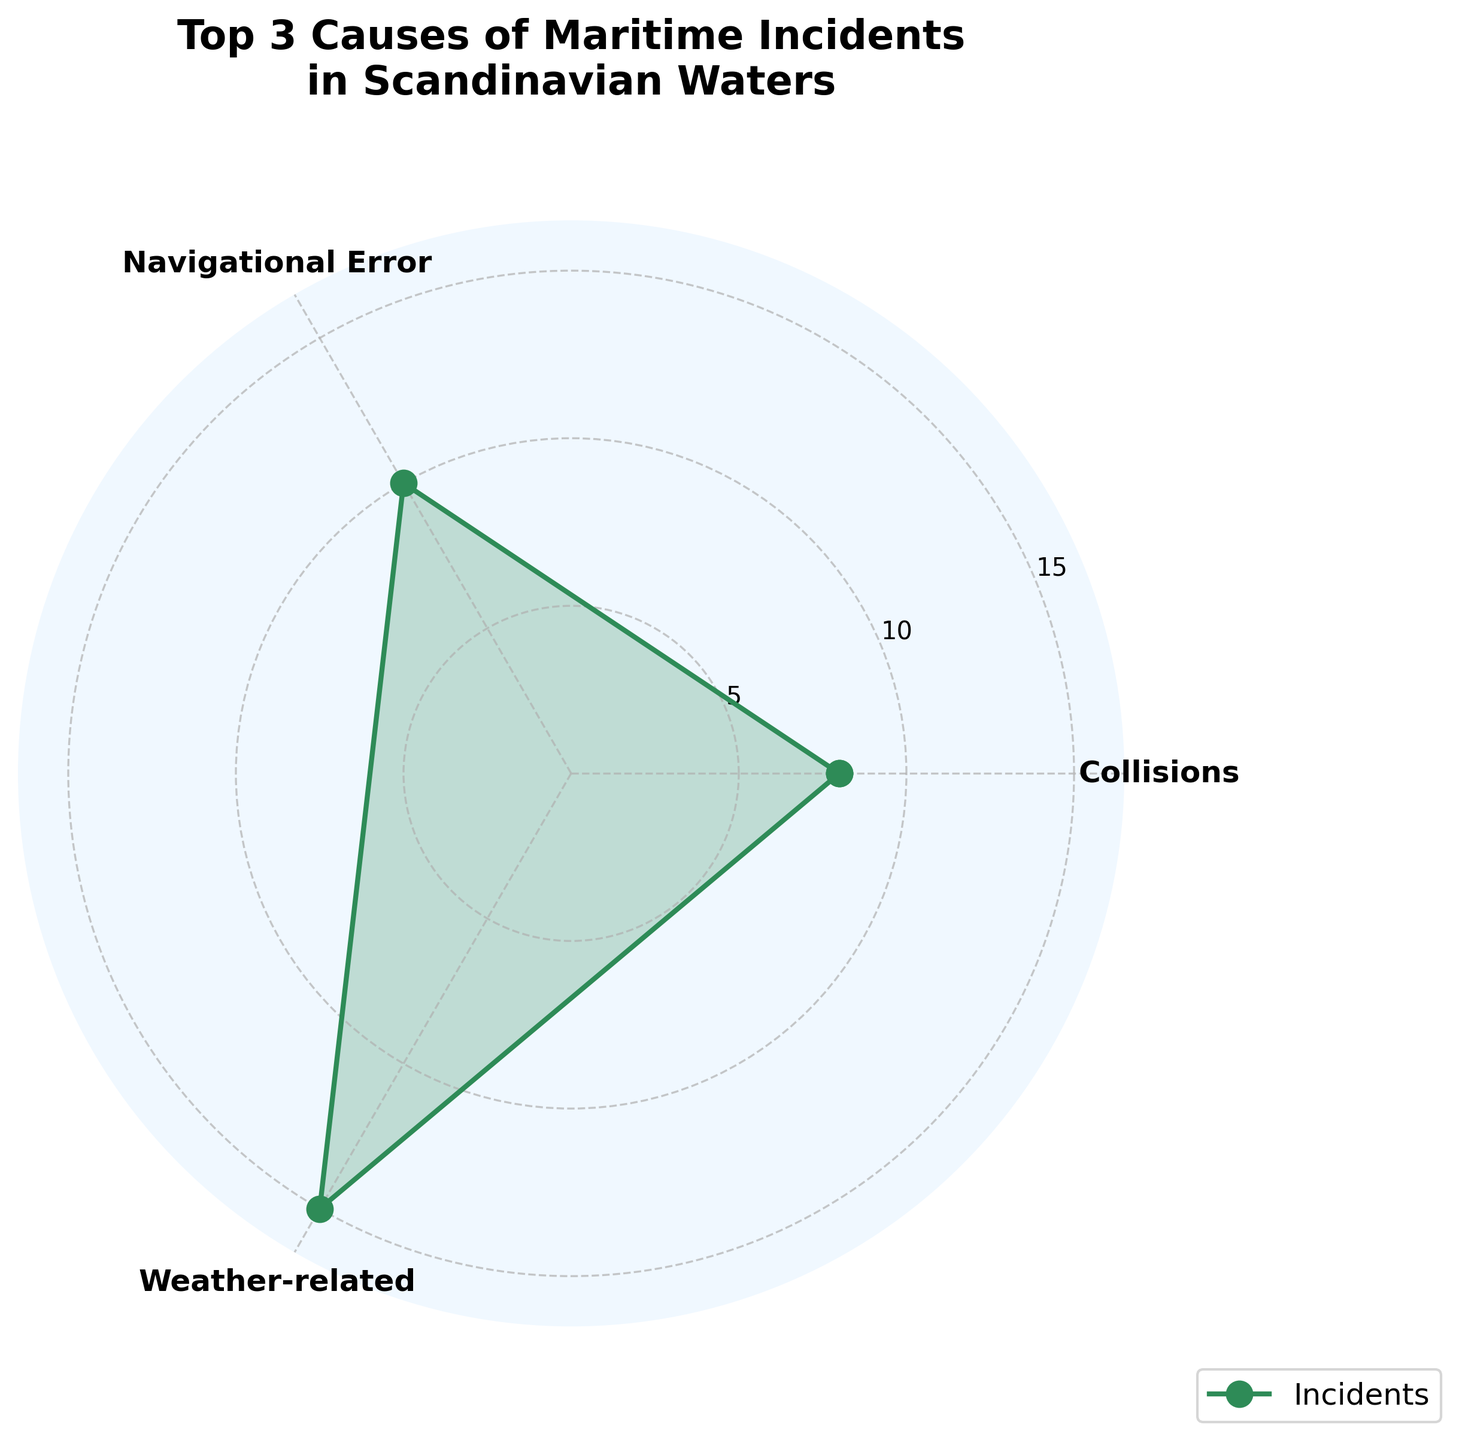What is the title of the figure? The title of the figure is displayed at the top in a large and bold font.
Answer: Top 3 Causes of Maritime Incidents in Scandinavian Waters How many causes are depicted in the rose chart? Count the number of unique labels on the angular axis of the rose chart.
Answer: 3 Which cause has the most incidents? Observe the length of the plots on the radial axis and identify which is the longest.
Answer: Weather-related How many incidents are related to navigational errors? Observe the label "Navigational Error" and note the value at that angular point.
Answer: 10 Which cause has the least number of incidents among the top 3? Compare the lengths of the plots and determine which is the shortest.
Answer: Mechanical Failure What is the total number of incidents for the top 3 causes? Sum the number of incidents for the top 3 causes: Weather-related (15), Navigational Error (10), Mechanical Failure (7). 15 + 10 + 7 = 32
Answer: 32 Which two causes combined account for more than half of the incidents? Determine combinations of causes that sum to more than 32 / 2 = 16 incidents: Weather-related (15) + Navigational Error (10).
Answer: Weather-related and Navigational Error How does the number of incidents caused by navigational errors compare with mechanical failures? Subtract the number of incidents for Mechanical Failure from Navigational Error: 10 - 7 = 3.
Answer: Navigational Error is higher by 3 What is the average number of incidents for the top 3 causes? Sum the number of incidents for the top 3 causes (32) and then divide by 3. 32 / 3 ≈ 10.67
Answer: Approximately 10.67 Which cause shows an intermediate number of incidents between the highest and lowest in the top 3? Identify the cause with the number of incidents between the maximum and minimum values.
Answer: Navigational Error 